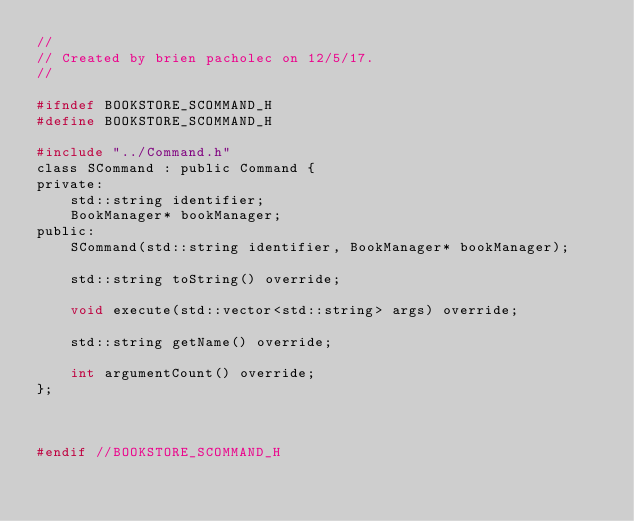Convert code to text. <code><loc_0><loc_0><loc_500><loc_500><_C_>//
// Created by brien pacholec on 12/5/17.
//

#ifndef BOOKSTORE_SCOMMAND_H
#define BOOKSTORE_SCOMMAND_H

#include "../Command.h"
class SCommand : public Command {
private:
    std::string identifier;
    BookManager* bookManager;
public:
    SCommand(std::string identifier, BookManager* bookManager);

    std::string toString() override;

    void execute(std::vector<std::string> args) override;

    std::string getName() override;

    int argumentCount() override;
};



#endif //BOOKSTORE_SCOMMAND_H
</code> 